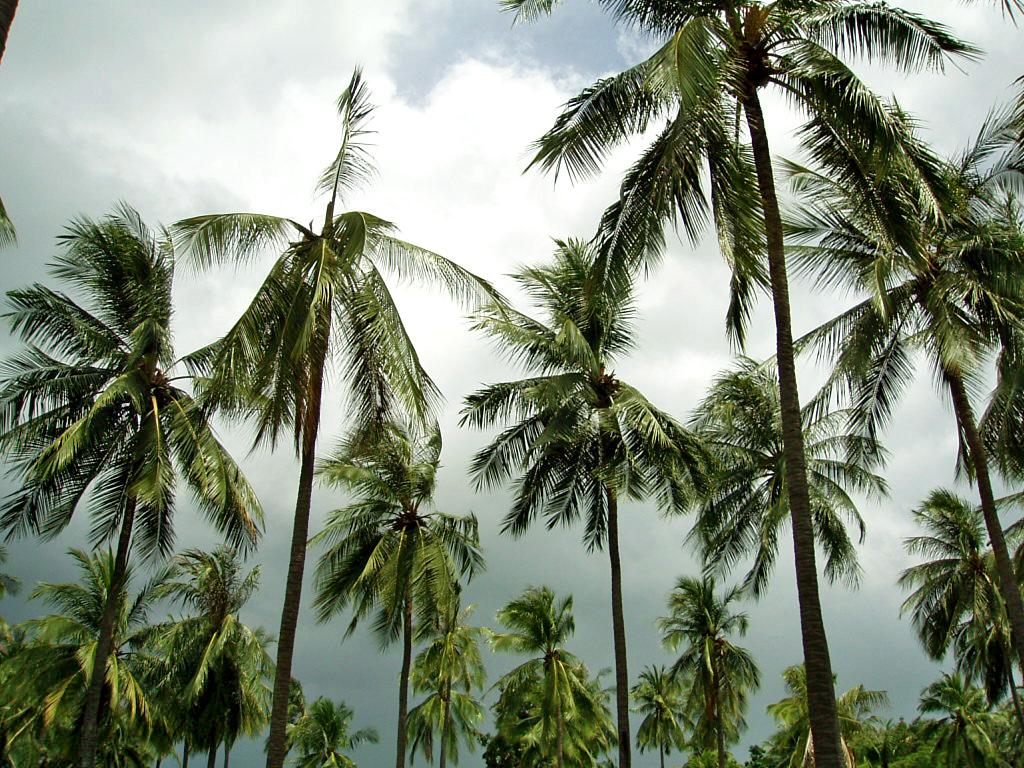What type of vegetation can be seen in the image? There are trees in the image. What is the color of the trees? The trees are green in color. What can be seen in the background of the image? The sky is visible in the background of the image. What colors are present in the sky? The sky has both white and blue colors. How does the boy increase the stitch count in the image? There is no boy or stitching activity present in the image; it features trees and a sky with white and blue colors. 